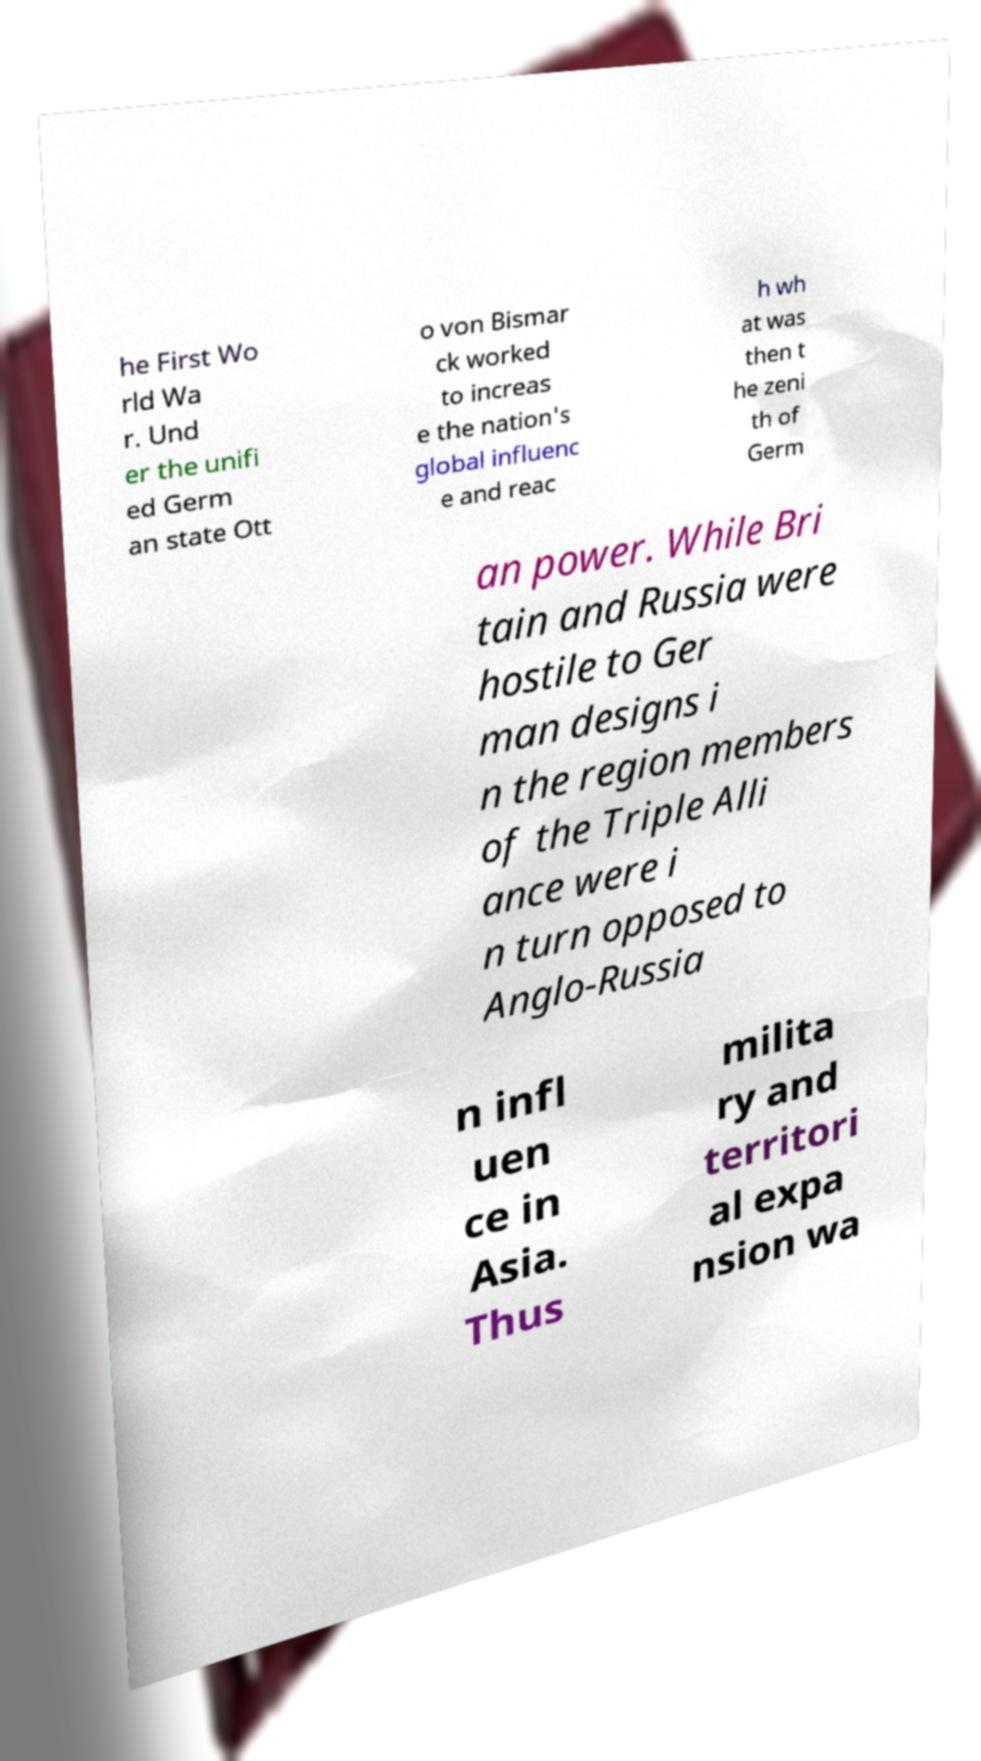For documentation purposes, I need the text within this image transcribed. Could you provide that? he First Wo rld Wa r. Und er the unifi ed Germ an state Ott o von Bismar ck worked to increas e the nation's global influenc e and reac h wh at was then t he zeni th of Germ an power. While Bri tain and Russia were hostile to Ger man designs i n the region members of the Triple Alli ance were i n turn opposed to Anglo-Russia n infl uen ce in Asia. Thus milita ry and territori al expa nsion wa 